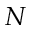Convert formula to latex. <formula><loc_0><loc_0><loc_500><loc_500>N</formula> 